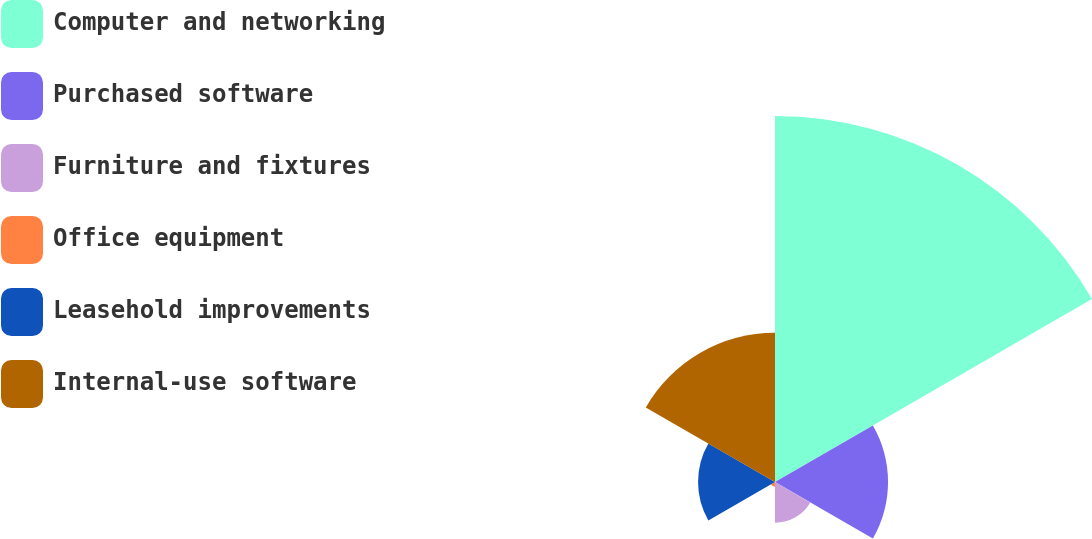<chart> <loc_0><loc_0><loc_500><loc_500><pie_chart><fcel>Computer and networking<fcel>Purchased software<fcel>Furniture and fixtures<fcel>Office equipment<fcel>Leasehold improvements<fcel>Internal-use software<nl><fcel>48.76%<fcel>15.06%<fcel>5.43%<fcel>0.62%<fcel>10.25%<fcel>19.88%<nl></chart> 